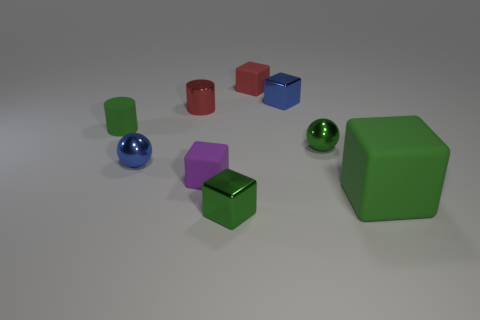Subtract all tiny purple blocks. How many blocks are left? 4 Subtract all green balls. How many balls are left? 1 Add 1 purple metallic cylinders. How many objects exist? 10 Subtract 1 red blocks. How many objects are left? 8 Subtract all blocks. How many objects are left? 4 Subtract all gray cylinders. Subtract all blue cubes. How many cylinders are left? 2 Subtract all brown spheres. How many green cylinders are left? 1 Subtract all blocks. Subtract all small green cylinders. How many objects are left? 3 Add 5 red blocks. How many red blocks are left? 6 Add 8 tiny yellow rubber spheres. How many tiny yellow rubber spheres exist? 8 